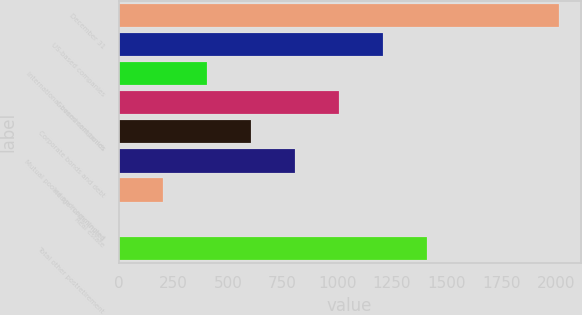<chart> <loc_0><loc_0><loc_500><loc_500><bar_chart><fcel>December 31<fcel>US-based companies<fcel>International-based companies<fcel>Government bonds<fcel>Corporate bonds and debt<fcel>Mutual pooled and commingled<fcel>Hedge funds/limited<fcel>Real estate<fcel>Total other postretirement<nl><fcel>2012<fcel>1208<fcel>404<fcel>1007<fcel>605<fcel>806<fcel>203<fcel>2<fcel>1409<nl></chart> 